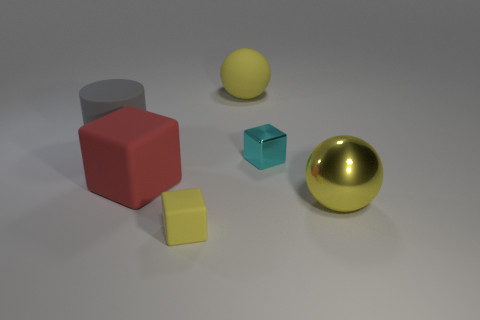Subtract all small yellow blocks. How many blocks are left? 2 Add 4 matte objects. How many objects exist? 10 Subtract all cylinders. How many objects are left? 5 Subtract all purple cubes. Subtract all blue cylinders. How many cubes are left? 3 Add 1 large cylinders. How many large cylinders exist? 2 Subtract 0 blue cubes. How many objects are left? 6 Subtract all small metallic cubes. Subtract all small cyan blocks. How many objects are left? 4 Add 4 gray matte cylinders. How many gray matte cylinders are left? 5 